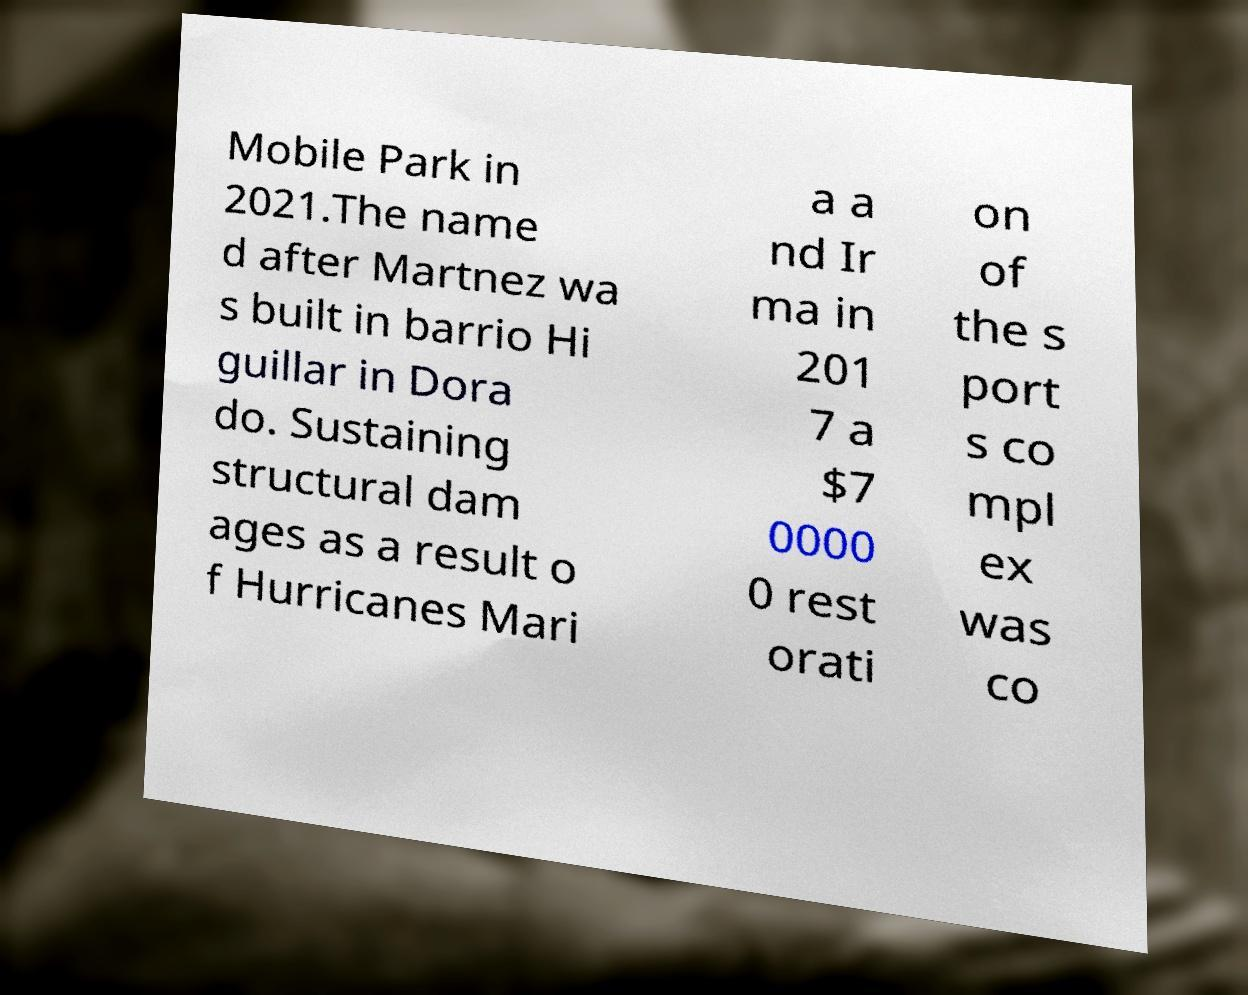Could you assist in decoding the text presented in this image and type it out clearly? Mobile Park in 2021.The name d after Martnez wa s built in barrio Hi guillar in Dora do. Sustaining structural dam ages as a result o f Hurricanes Mari a a nd Ir ma in 201 7 a $7 0000 0 rest orati on of the s port s co mpl ex was co 